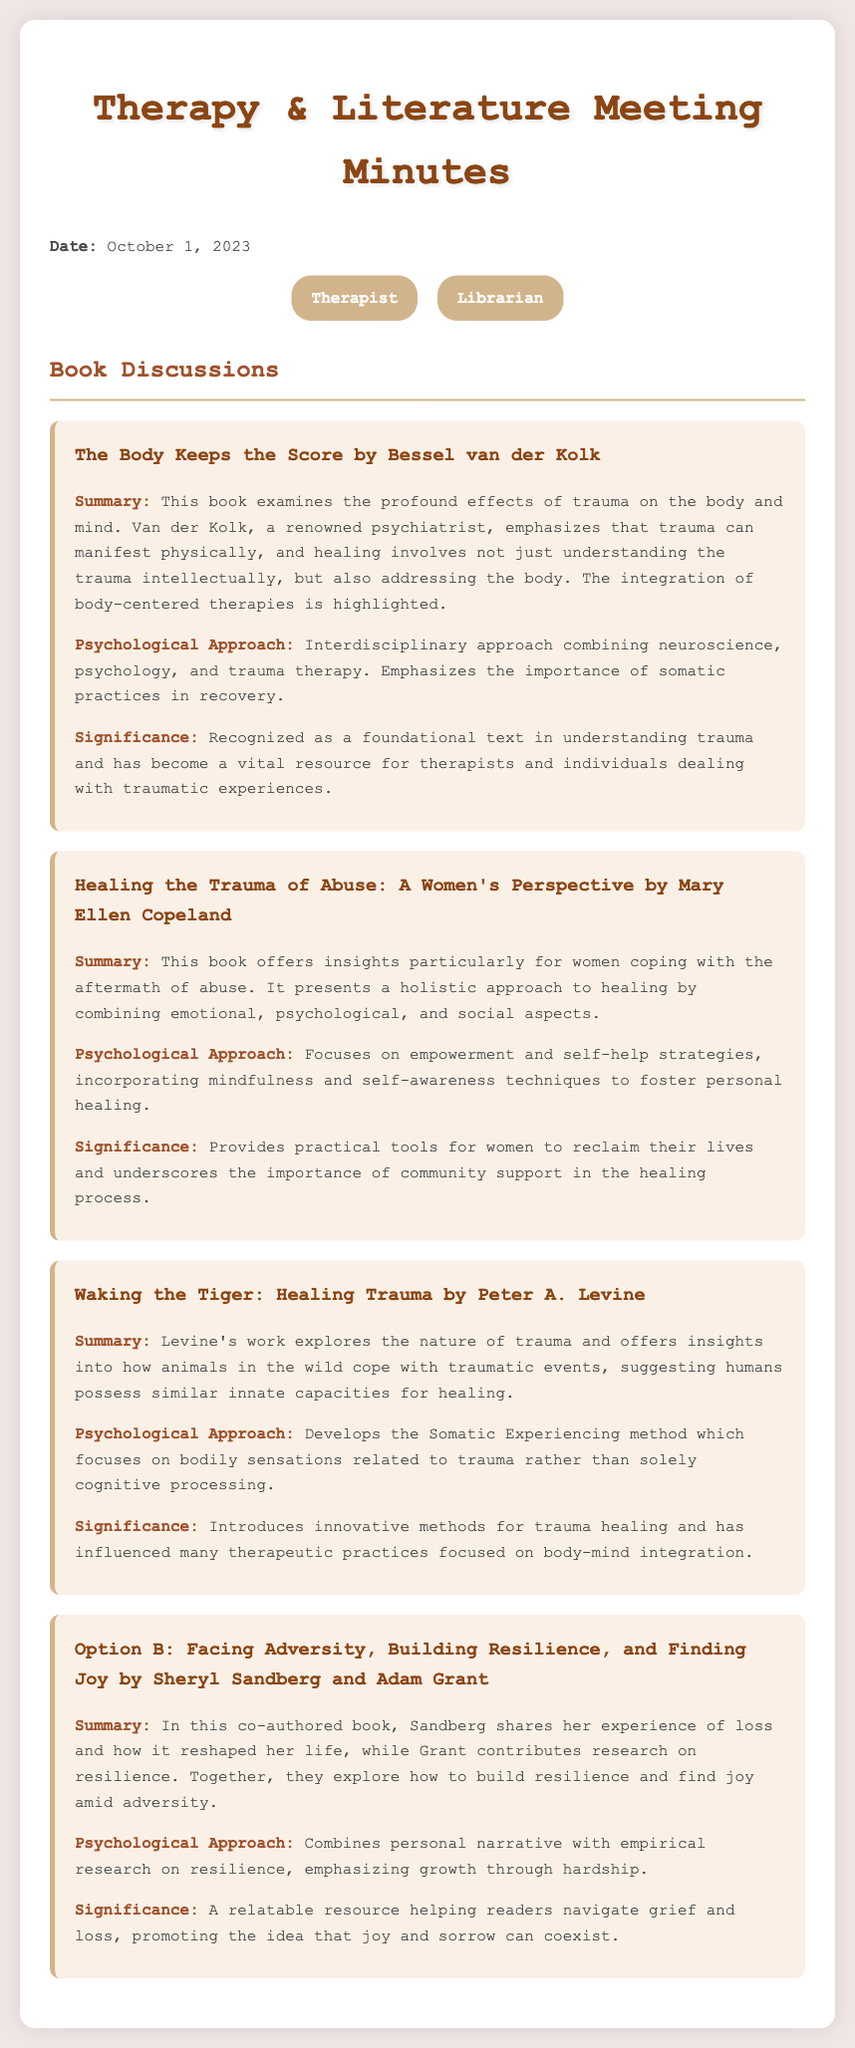What is the title of the first book discussed? The title of the first book is listed in the document under the book discussions section.
Answer: The Body Keeps the Score by Bessel van der Kolk Who is the author of "Healing the Trauma of Abuse: A Women's Perspective"? The author is mentioned directly following the title of the book.
Answer: Mary Ellen Copeland What is the publication date of the meeting? The meeting's date is placed at the beginning of the document, indicating when it took place.
Answer: October 1, 2023 What is one key approach discussed in "Waking the Tiger: Healing Trauma"? The psychological approach is outlined in the book summary, detailing the method used by the author.
Answer: Somatic Experiencing method How many people attended the meeting? The attendees section lists the participants present in the meeting.
Answer: Two What psychological aspect is emphasized in "Option B"? The document specifies this aspect in the summary section of the book.
Answer: Resilience What is the significance of "The Body Keeps the Score"? The significance section of the book highlights its impact and importance in understanding trauma.
Answer: Foundational text in understanding trauma What type of audience is "Healing the Trauma of Abuse" aimed at? The summary provides insight into the target audience for the book.
Answer: Women 